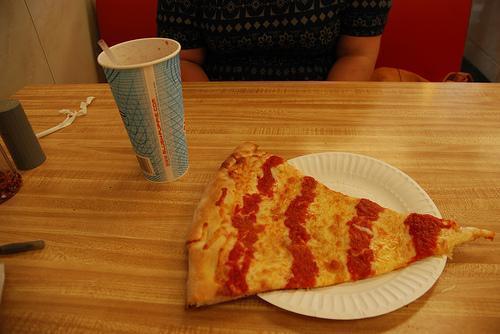How many slices of pizza are on the plate?
Give a very brief answer. 1. 